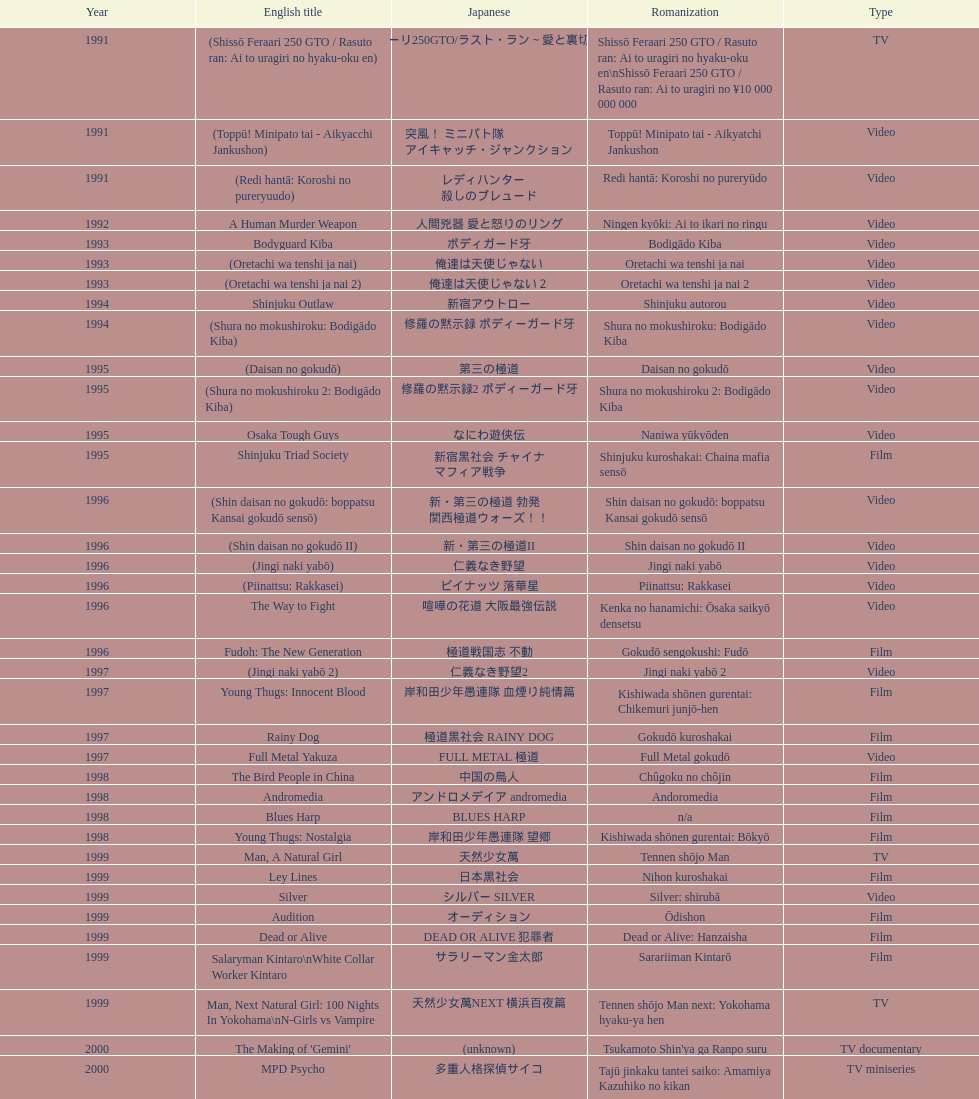What is a movie that was launched before the year 1996? Shinjuku Triad Society. 